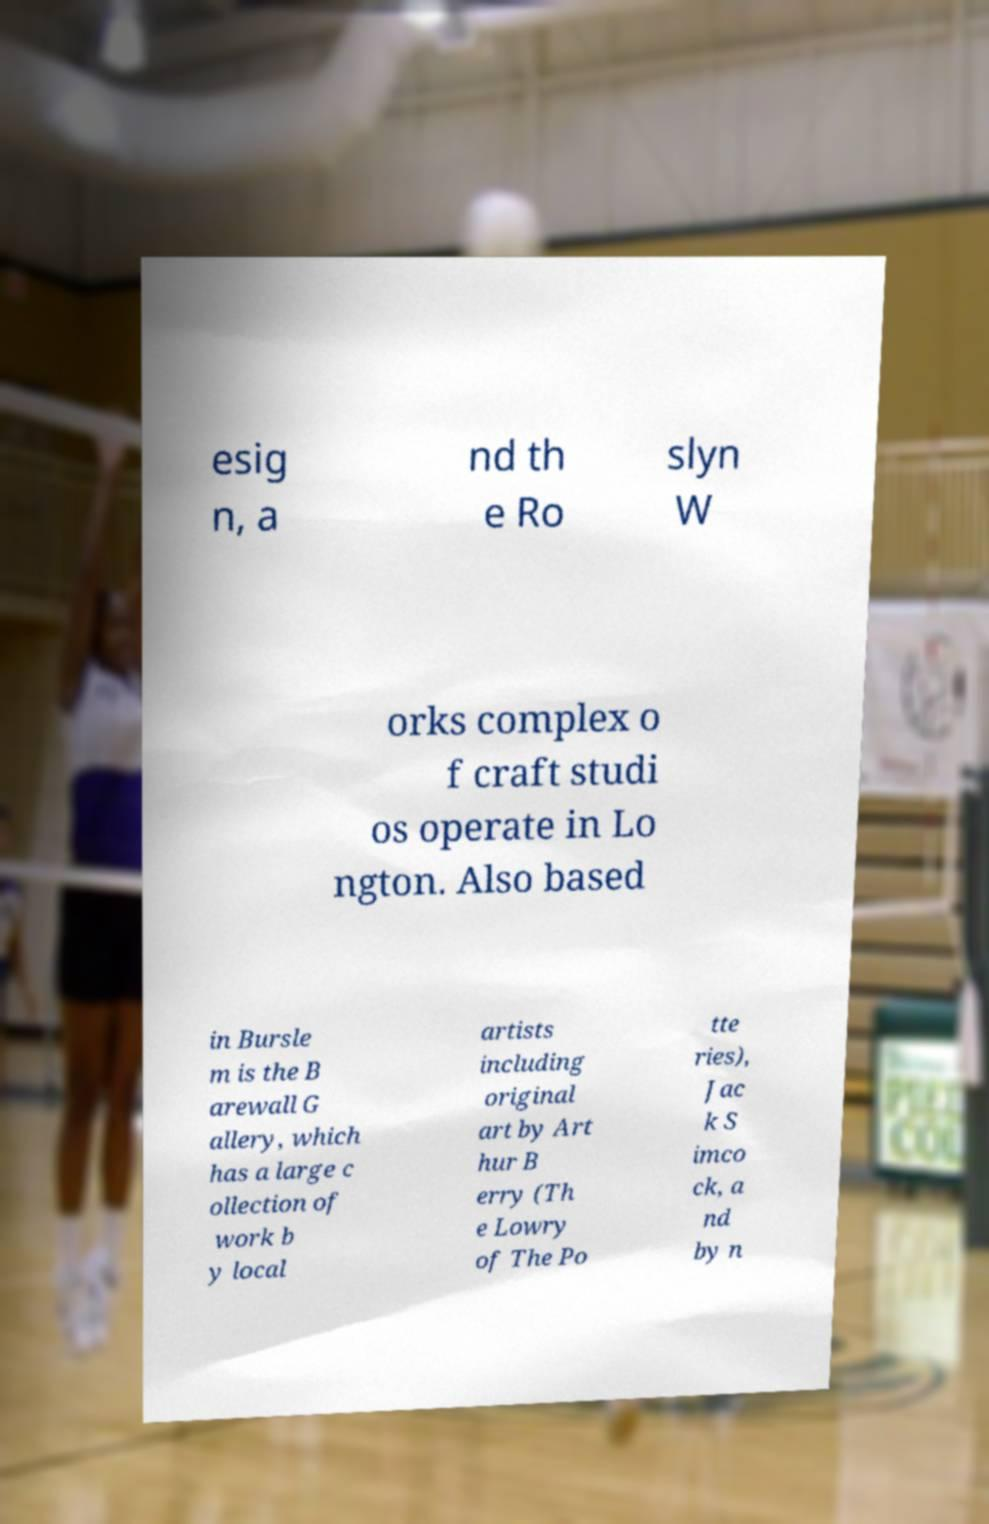Could you assist in decoding the text presented in this image and type it out clearly? esig n, a nd th e Ro slyn W orks complex o f craft studi os operate in Lo ngton. Also based in Bursle m is the B arewall G allery, which has a large c ollection of work b y local artists including original art by Art hur B erry (Th e Lowry of The Po tte ries), Jac k S imco ck, a nd by n 